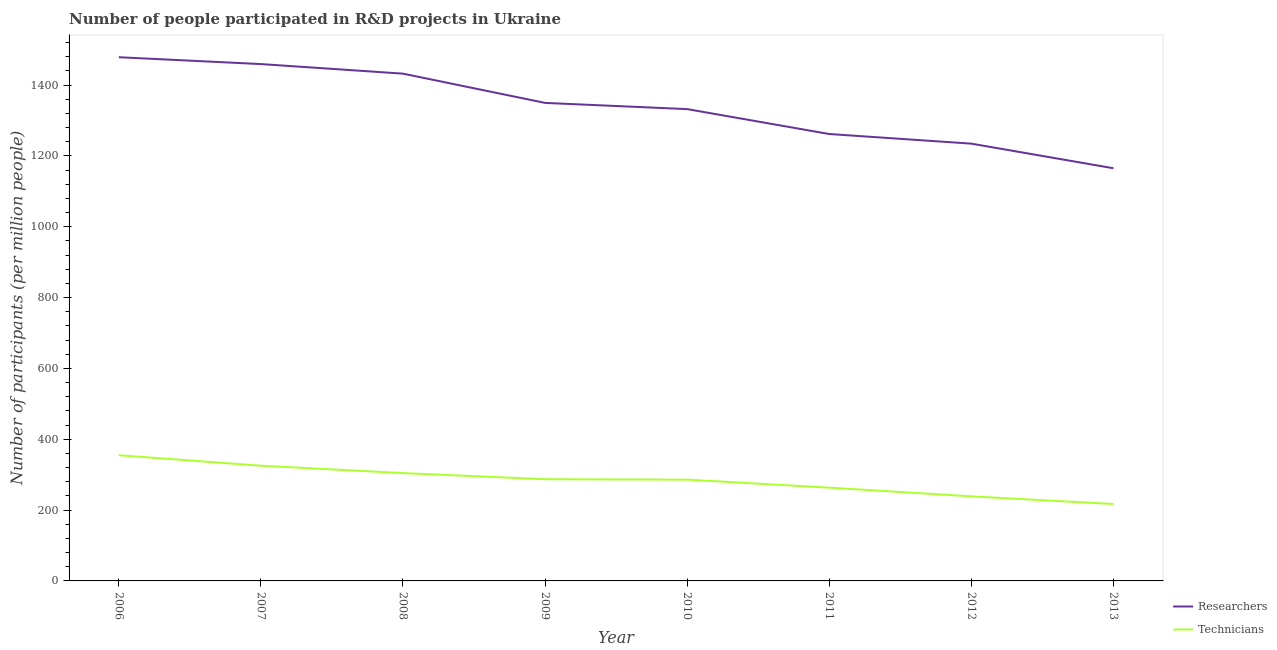How many different coloured lines are there?
Keep it short and to the point. 2. What is the number of researchers in 2011?
Make the answer very short. 1261.86. Across all years, what is the maximum number of technicians?
Make the answer very short. 354.95. Across all years, what is the minimum number of technicians?
Make the answer very short. 217.23. In which year was the number of technicians minimum?
Your answer should be very brief. 2013. What is the total number of technicians in the graph?
Your response must be concise. 2277.25. What is the difference between the number of researchers in 2010 and that in 2012?
Keep it short and to the point. 97.54. What is the difference between the number of researchers in 2010 and the number of technicians in 2011?
Give a very brief answer. 1068.84. What is the average number of researchers per year?
Your answer should be compact. 1339.25. In the year 2009, what is the difference between the number of technicians and number of researchers?
Keep it short and to the point. -1062.52. In how many years, is the number of technicians greater than 40?
Offer a very short reply. 8. What is the ratio of the number of technicians in 2009 to that in 2012?
Offer a terse response. 1.2. Is the number of technicians in 2009 less than that in 2012?
Ensure brevity in your answer.  No. What is the difference between the highest and the second highest number of researchers?
Ensure brevity in your answer.  19.39. What is the difference between the highest and the lowest number of researchers?
Your response must be concise. 313.53. Is the sum of the number of technicians in 2009 and 2012 greater than the maximum number of researchers across all years?
Provide a short and direct response. No. Does the number of researchers monotonically increase over the years?
Offer a very short reply. No. Is the number of researchers strictly greater than the number of technicians over the years?
Your answer should be very brief. Yes. How many lines are there?
Your answer should be very brief. 2. How many legend labels are there?
Your response must be concise. 2. What is the title of the graph?
Keep it short and to the point. Number of people participated in R&D projects in Ukraine. What is the label or title of the Y-axis?
Keep it short and to the point. Number of participants (per million people). What is the Number of participants (per million people) of Researchers in 2006?
Offer a terse response. 1478.72. What is the Number of participants (per million people) in Technicians in 2006?
Your answer should be very brief. 354.95. What is the Number of participants (per million people) in Researchers in 2007?
Keep it short and to the point. 1459.32. What is the Number of participants (per million people) in Technicians in 2007?
Offer a very short reply. 325.3. What is the Number of participants (per million people) in Researchers in 2008?
Provide a succinct answer. 1432.33. What is the Number of participants (per million people) of Technicians in 2008?
Give a very brief answer. 304.47. What is the Number of participants (per million people) in Researchers in 2009?
Your response must be concise. 1349.71. What is the Number of participants (per million people) of Technicians in 2009?
Your response must be concise. 287.19. What is the Number of participants (per million people) of Researchers in 2010?
Your answer should be compact. 1332.2. What is the Number of participants (per million people) of Technicians in 2010?
Ensure brevity in your answer.  285.95. What is the Number of participants (per million people) of Researchers in 2011?
Your answer should be very brief. 1261.86. What is the Number of participants (per million people) in Technicians in 2011?
Provide a succinct answer. 263.36. What is the Number of participants (per million people) of Researchers in 2012?
Keep it short and to the point. 1234.66. What is the Number of participants (per million people) of Technicians in 2012?
Offer a very short reply. 238.79. What is the Number of participants (per million people) in Researchers in 2013?
Keep it short and to the point. 1165.18. What is the Number of participants (per million people) of Technicians in 2013?
Offer a terse response. 217.23. Across all years, what is the maximum Number of participants (per million people) in Researchers?
Your response must be concise. 1478.72. Across all years, what is the maximum Number of participants (per million people) in Technicians?
Your answer should be compact. 354.95. Across all years, what is the minimum Number of participants (per million people) in Researchers?
Provide a short and direct response. 1165.18. Across all years, what is the minimum Number of participants (per million people) of Technicians?
Make the answer very short. 217.23. What is the total Number of participants (per million people) of Researchers in the graph?
Keep it short and to the point. 1.07e+04. What is the total Number of participants (per million people) of Technicians in the graph?
Provide a short and direct response. 2277.25. What is the difference between the Number of participants (per million people) in Researchers in 2006 and that in 2007?
Offer a terse response. 19.39. What is the difference between the Number of participants (per million people) in Technicians in 2006 and that in 2007?
Keep it short and to the point. 29.65. What is the difference between the Number of participants (per million people) of Researchers in 2006 and that in 2008?
Provide a short and direct response. 46.39. What is the difference between the Number of participants (per million people) of Technicians in 2006 and that in 2008?
Give a very brief answer. 50.49. What is the difference between the Number of participants (per million people) of Researchers in 2006 and that in 2009?
Your answer should be compact. 129. What is the difference between the Number of participants (per million people) of Technicians in 2006 and that in 2009?
Your answer should be compact. 67.76. What is the difference between the Number of participants (per million people) in Researchers in 2006 and that in 2010?
Ensure brevity in your answer.  146.52. What is the difference between the Number of participants (per million people) in Technicians in 2006 and that in 2010?
Provide a succinct answer. 69.01. What is the difference between the Number of participants (per million people) of Researchers in 2006 and that in 2011?
Offer a very short reply. 216.86. What is the difference between the Number of participants (per million people) in Technicians in 2006 and that in 2011?
Offer a very short reply. 91.59. What is the difference between the Number of participants (per million people) in Researchers in 2006 and that in 2012?
Your answer should be very brief. 244.05. What is the difference between the Number of participants (per million people) in Technicians in 2006 and that in 2012?
Keep it short and to the point. 116.16. What is the difference between the Number of participants (per million people) in Researchers in 2006 and that in 2013?
Your answer should be compact. 313.53. What is the difference between the Number of participants (per million people) of Technicians in 2006 and that in 2013?
Offer a terse response. 137.72. What is the difference between the Number of participants (per million people) of Researchers in 2007 and that in 2008?
Offer a very short reply. 26.99. What is the difference between the Number of participants (per million people) of Technicians in 2007 and that in 2008?
Offer a terse response. 20.83. What is the difference between the Number of participants (per million people) in Researchers in 2007 and that in 2009?
Your answer should be compact. 109.61. What is the difference between the Number of participants (per million people) in Technicians in 2007 and that in 2009?
Provide a succinct answer. 38.11. What is the difference between the Number of participants (per million people) in Researchers in 2007 and that in 2010?
Your answer should be compact. 127.12. What is the difference between the Number of participants (per million people) in Technicians in 2007 and that in 2010?
Your answer should be compact. 39.36. What is the difference between the Number of participants (per million people) of Researchers in 2007 and that in 2011?
Your answer should be very brief. 197.46. What is the difference between the Number of participants (per million people) in Technicians in 2007 and that in 2011?
Your answer should be very brief. 61.94. What is the difference between the Number of participants (per million people) in Researchers in 2007 and that in 2012?
Ensure brevity in your answer.  224.66. What is the difference between the Number of participants (per million people) in Technicians in 2007 and that in 2012?
Offer a terse response. 86.51. What is the difference between the Number of participants (per million people) in Researchers in 2007 and that in 2013?
Provide a succinct answer. 294.14. What is the difference between the Number of participants (per million people) in Technicians in 2007 and that in 2013?
Ensure brevity in your answer.  108.07. What is the difference between the Number of participants (per million people) of Researchers in 2008 and that in 2009?
Your answer should be very brief. 82.62. What is the difference between the Number of participants (per million people) of Technicians in 2008 and that in 2009?
Offer a terse response. 17.28. What is the difference between the Number of participants (per million people) of Researchers in 2008 and that in 2010?
Offer a very short reply. 100.13. What is the difference between the Number of participants (per million people) of Technicians in 2008 and that in 2010?
Your response must be concise. 18.52. What is the difference between the Number of participants (per million people) in Researchers in 2008 and that in 2011?
Offer a terse response. 170.47. What is the difference between the Number of participants (per million people) of Technicians in 2008 and that in 2011?
Give a very brief answer. 41.11. What is the difference between the Number of participants (per million people) in Researchers in 2008 and that in 2012?
Your response must be concise. 197.67. What is the difference between the Number of participants (per million people) in Technicians in 2008 and that in 2012?
Make the answer very short. 65.68. What is the difference between the Number of participants (per million people) in Researchers in 2008 and that in 2013?
Your response must be concise. 267.15. What is the difference between the Number of participants (per million people) in Technicians in 2008 and that in 2013?
Provide a short and direct response. 87.23. What is the difference between the Number of participants (per million people) of Researchers in 2009 and that in 2010?
Ensure brevity in your answer.  17.51. What is the difference between the Number of participants (per million people) in Technicians in 2009 and that in 2010?
Your answer should be very brief. 1.24. What is the difference between the Number of participants (per million people) in Researchers in 2009 and that in 2011?
Offer a very short reply. 87.85. What is the difference between the Number of participants (per million people) in Technicians in 2009 and that in 2011?
Ensure brevity in your answer.  23.83. What is the difference between the Number of participants (per million people) of Researchers in 2009 and that in 2012?
Your answer should be very brief. 115.05. What is the difference between the Number of participants (per million people) of Technicians in 2009 and that in 2012?
Your answer should be compact. 48.4. What is the difference between the Number of participants (per million people) in Researchers in 2009 and that in 2013?
Provide a short and direct response. 184.53. What is the difference between the Number of participants (per million people) of Technicians in 2009 and that in 2013?
Keep it short and to the point. 69.96. What is the difference between the Number of participants (per million people) in Researchers in 2010 and that in 2011?
Your answer should be very brief. 70.34. What is the difference between the Number of participants (per million people) in Technicians in 2010 and that in 2011?
Make the answer very short. 22.59. What is the difference between the Number of participants (per million people) in Researchers in 2010 and that in 2012?
Your answer should be very brief. 97.54. What is the difference between the Number of participants (per million people) of Technicians in 2010 and that in 2012?
Your answer should be very brief. 47.16. What is the difference between the Number of participants (per million people) in Researchers in 2010 and that in 2013?
Your answer should be compact. 167.02. What is the difference between the Number of participants (per million people) of Technicians in 2010 and that in 2013?
Offer a terse response. 68.71. What is the difference between the Number of participants (per million people) of Researchers in 2011 and that in 2012?
Your answer should be very brief. 27.2. What is the difference between the Number of participants (per million people) of Technicians in 2011 and that in 2012?
Your answer should be compact. 24.57. What is the difference between the Number of participants (per million people) in Researchers in 2011 and that in 2013?
Make the answer very short. 96.68. What is the difference between the Number of participants (per million people) in Technicians in 2011 and that in 2013?
Keep it short and to the point. 46.13. What is the difference between the Number of participants (per million people) of Researchers in 2012 and that in 2013?
Your response must be concise. 69.48. What is the difference between the Number of participants (per million people) in Technicians in 2012 and that in 2013?
Provide a short and direct response. 21.56. What is the difference between the Number of participants (per million people) of Researchers in 2006 and the Number of participants (per million people) of Technicians in 2007?
Provide a succinct answer. 1153.41. What is the difference between the Number of participants (per million people) in Researchers in 2006 and the Number of participants (per million people) in Technicians in 2008?
Provide a succinct answer. 1174.25. What is the difference between the Number of participants (per million people) of Researchers in 2006 and the Number of participants (per million people) of Technicians in 2009?
Ensure brevity in your answer.  1191.52. What is the difference between the Number of participants (per million people) of Researchers in 2006 and the Number of participants (per million people) of Technicians in 2010?
Your response must be concise. 1192.77. What is the difference between the Number of participants (per million people) in Researchers in 2006 and the Number of participants (per million people) in Technicians in 2011?
Offer a terse response. 1215.36. What is the difference between the Number of participants (per million people) in Researchers in 2006 and the Number of participants (per million people) in Technicians in 2012?
Your answer should be very brief. 1239.93. What is the difference between the Number of participants (per million people) in Researchers in 2006 and the Number of participants (per million people) in Technicians in 2013?
Offer a very short reply. 1261.48. What is the difference between the Number of participants (per million people) in Researchers in 2007 and the Number of participants (per million people) in Technicians in 2008?
Provide a succinct answer. 1154.85. What is the difference between the Number of participants (per million people) in Researchers in 2007 and the Number of participants (per million people) in Technicians in 2009?
Your response must be concise. 1172.13. What is the difference between the Number of participants (per million people) in Researchers in 2007 and the Number of participants (per million people) in Technicians in 2010?
Your answer should be very brief. 1173.37. What is the difference between the Number of participants (per million people) of Researchers in 2007 and the Number of participants (per million people) of Technicians in 2011?
Provide a short and direct response. 1195.96. What is the difference between the Number of participants (per million people) in Researchers in 2007 and the Number of participants (per million people) in Technicians in 2012?
Your response must be concise. 1220.53. What is the difference between the Number of participants (per million people) of Researchers in 2007 and the Number of participants (per million people) of Technicians in 2013?
Your response must be concise. 1242.09. What is the difference between the Number of participants (per million people) in Researchers in 2008 and the Number of participants (per million people) in Technicians in 2009?
Provide a short and direct response. 1145.14. What is the difference between the Number of participants (per million people) of Researchers in 2008 and the Number of participants (per million people) of Technicians in 2010?
Give a very brief answer. 1146.38. What is the difference between the Number of participants (per million people) in Researchers in 2008 and the Number of participants (per million people) in Technicians in 2011?
Your answer should be very brief. 1168.97. What is the difference between the Number of participants (per million people) of Researchers in 2008 and the Number of participants (per million people) of Technicians in 2012?
Make the answer very short. 1193.54. What is the difference between the Number of participants (per million people) in Researchers in 2008 and the Number of participants (per million people) in Technicians in 2013?
Make the answer very short. 1215.1. What is the difference between the Number of participants (per million people) in Researchers in 2009 and the Number of participants (per million people) in Technicians in 2010?
Give a very brief answer. 1063.76. What is the difference between the Number of participants (per million people) in Researchers in 2009 and the Number of participants (per million people) in Technicians in 2011?
Provide a succinct answer. 1086.35. What is the difference between the Number of participants (per million people) in Researchers in 2009 and the Number of participants (per million people) in Technicians in 2012?
Ensure brevity in your answer.  1110.92. What is the difference between the Number of participants (per million people) in Researchers in 2009 and the Number of participants (per million people) in Technicians in 2013?
Ensure brevity in your answer.  1132.48. What is the difference between the Number of participants (per million people) in Researchers in 2010 and the Number of participants (per million people) in Technicians in 2011?
Give a very brief answer. 1068.84. What is the difference between the Number of participants (per million people) of Researchers in 2010 and the Number of participants (per million people) of Technicians in 2012?
Offer a very short reply. 1093.41. What is the difference between the Number of participants (per million people) in Researchers in 2010 and the Number of participants (per million people) in Technicians in 2013?
Make the answer very short. 1114.96. What is the difference between the Number of participants (per million people) of Researchers in 2011 and the Number of participants (per million people) of Technicians in 2012?
Give a very brief answer. 1023.07. What is the difference between the Number of participants (per million people) in Researchers in 2011 and the Number of participants (per million people) in Technicians in 2013?
Provide a succinct answer. 1044.63. What is the difference between the Number of participants (per million people) in Researchers in 2012 and the Number of participants (per million people) in Technicians in 2013?
Provide a succinct answer. 1017.43. What is the average Number of participants (per million people) in Researchers per year?
Your response must be concise. 1339.25. What is the average Number of participants (per million people) of Technicians per year?
Give a very brief answer. 284.66. In the year 2006, what is the difference between the Number of participants (per million people) in Researchers and Number of participants (per million people) in Technicians?
Your response must be concise. 1123.76. In the year 2007, what is the difference between the Number of participants (per million people) in Researchers and Number of participants (per million people) in Technicians?
Make the answer very short. 1134.02. In the year 2008, what is the difference between the Number of participants (per million people) of Researchers and Number of participants (per million people) of Technicians?
Your answer should be compact. 1127.86. In the year 2009, what is the difference between the Number of participants (per million people) of Researchers and Number of participants (per million people) of Technicians?
Provide a short and direct response. 1062.52. In the year 2010, what is the difference between the Number of participants (per million people) of Researchers and Number of participants (per million people) of Technicians?
Your answer should be very brief. 1046.25. In the year 2011, what is the difference between the Number of participants (per million people) in Researchers and Number of participants (per million people) in Technicians?
Ensure brevity in your answer.  998.5. In the year 2012, what is the difference between the Number of participants (per million people) in Researchers and Number of participants (per million people) in Technicians?
Your response must be concise. 995.87. In the year 2013, what is the difference between the Number of participants (per million people) in Researchers and Number of participants (per million people) in Technicians?
Your answer should be compact. 947.95. What is the ratio of the Number of participants (per million people) of Researchers in 2006 to that in 2007?
Give a very brief answer. 1.01. What is the ratio of the Number of participants (per million people) in Technicians in 2006 to that in 2007?
Provide a succinct answer. 1.09. What is the ratio of the Number of participants (per million people) of Researchers in 2006 to that in 2008?
Your answer should be very brief. 1.03. What is the ratio of the Number of participants (per million people) in Technicians in 2006 to that in 2008?
Give a very brief answer. 1.17. What is the ratio of the Number of participants (per million people) in Researchers in 2006 to that in 2009?
Your response must be concise. 1.1. What is the ratio of the Number of participants (per million people) in Technicians in 2006 to that in 2009?
Your answer should be compact. 1.24. What is the ratio of the Number of participants (per million people) of Researchers in 2006 to that in 2010?
Keep it short and to the point. 1.11. What is the ratio of the Number of participants (per million people) of Technicians in 2006 to that in 2010?
Provide a succinct answer. 1.24. What is the ratio of the Number of participants (per million people) in Researchers in 2006 to that in 2011?
Give a very brief answer. 1.17. What is the ratio of the Number of participants (per million people) in Technicians in 2006 to that in 2011?
Your answer should be very brief. 1.35. What is the ratio of the Number of participants (per million people) in Researchers in 2006 to that in 2012?
Offer a very short reply. 1.2. What is the ratio of the Number of participants (per million people) of Technicians in 2006 to that in 2012?
Provide a succinct answer. 1.49. What is the ratio of the Number of participants (per million people) of Researchers in 2006 to that in 2013?
Provide a short and direct response. 1.27. What is the ratio of the Number of participants (per million people) of Technicians in 2006 to that in 2013?
Offer a very short reply. 1.63. What is the ratio of the Number of participants (per million people) in Researchers in 2007 to that in 2008?
Offer a terse response. 1.02. What is the ratio of the Number of participants (per million people) in Technicians in 2007 to that in 2008?
Offer a terse response. 1.07. What is the ratio of the Number of participants (per million people) in Researchers in 2007 to that in 2009?
Offer a terse response. 1.08. What is the ratio of the Number of participants (per million people) in Technicians in 2007 to that in 2009?
Give a very brief answer. 1.13. What is the ratio of the Number of participants (per million people) in Researchers in 2007 to that in 2010?
Ensure brevity in your answer.  1.1. What is the ratio of the Number of participants (per million people) of Technicians in 2007 to that in 2010?
Your answer should be very brief. 1.14. What is the ratio of the Number of participants (per million people) in Researchers in 2007 to that in 2011?
Your answer should be very brief. 1.16. What is the ratio of the Number of participants (per million people) in Technicians in 2007 to that in 2011?
Make the answer very short. 1.24. What is the ratio of the Number of participants (per million people) in Researchers in 2007 to that in 2012?
Your answer should be very brief. 1.18. What is the ratio of the Number of participants (per million people) in Technicians in 2007 to that in 2012?
Provide a succinct answer. 1.36. What is the ratio of the Number of participants (per million people) in Researchers in 2007 to that in 2013?
Give a very brief answer. 1.25. What is the ratio of the Number of participants (per million people) of Technicians in 2007 to that in 2013?
Give a very brief answer. 1.5. What is the ratio of the Number of participants (per million people) in Researchers in 2008 to that in 2009?
Make the answer very short. 1.06. What is the ratio of the Number of participants (per million people) of Technicians in 2008 to that in 2009?
Give a very brief answer. 1.06. What is the ratio of the Number of participants (per million people) of Researchers in 2008 to that in 2010?
Keep it short and to the point. 1.08. What is the ratio of the Number of participants (per million people) of Technicians in 2008 to that in 2010?
Your answer should be compact. 1.06. What is the ratio of the Number of participants (per million people) in Researchers in 2008 to that in 2011?
Your response must be concise. 1.14. What is the ratio of the Number of participants (per million people) in Technicians in 2008 to that in 2011?
Your answer should be compact. 1.16. What is the ratio of the Number of participants (per million people) of Researchers in 2008 to that in 2012?
Provide a short and direct response. 1.16. What is the ratio of the Number of participants (per million people) of Technicians in 2008 to that in 2012?
Your answer should be compact. 1.28. What is the ratio of the Number of participants (per million people) in Researchers in 2008 to that in 2013?
Ensure brevity in your answer.  1.23. What is the ratio of the Number of participants (per million people) of Technicians in 2008 to that in 2013?
Offer a terse response. 1.4. What is the ratio of the Number of participants (per million people) of Researchers in 2009 to that in 2010?
Make the answer very short. 1.01. What is the ratio of the Number of participants (per million people) in Researchers in 2009 to that in 2011?
Give a very brief answer. 1.07. What is the ratio of the Number of participants (per million people) in Technicians in 2009 to that in 2011?
Make the answer very short. 1.09. What is the ratio of the Number of participants (per million people) of Researchers in 2009 to that in 2012?
Your answer should be very brief. 1.09. What is the ratio of the Number of participants (per million people) in Technicians in 2009 to that in 2012?
Give a very brief answer. 1.2. What is the ratio of the Number of participants (per million people) of Researchers in 2009 to that in 2013?
Your response must be concise. 1.16. What is the ratio of the Number of participants (per million people) of Technicians in 2009 to that in 2013?
Your answer should be very brief. 1.32. What is the ratio of the Number of participants (per million people) of Researchers in 2010 to that in 2011?
Provide a succinct answer. 1.06. What is the ratio of the Number of participants (per million people) of Technicians in 2010 to that in 2011?
Your answer should be compact. 1.09. What is the ratio of the Number of participants (per million people) of Researchers in 2010 to that in 2012?
Keep it short and to the point. 1.08. What is the ratio of the Number of participants (per million people) in Technicians in 2010 to that in 2012?
Your answer should be compact. 1.2. What is the ratio of the Number of participants (per million people) in Researchers in 2010 to that in 2013?
Make the answer very short. 1.14. What is the ratio of the Number of participants (per million people) of Technicians in 2010 to that in 2013?
Provide a short and direct response. 1.32. What is the ratio of the Number of participants (per million people) in Researchers in 2011 to that in 2012?
Offer a terse response. 1.02. What is the ratio of the Number of participants (per million people) of Technicians in 2011 to that in 2012?
Ensure brevity in your answer.  1.1. What is the ratio of the Number of participants (per million people) in Researchers in 2011 to that in 2013?
Provide a short and direct response. 1.08. What is the ratio of the Number of participants (per million people) in Technicians in 2011 to that in 2013?
Your response must be concise. 1.21. What is the ratio of the Number of participants (per million people) of Researchers in 2012 to that in 2013?
Offer a very short reply. 1.06. What is the ratio of the Number of participants (per million people) in Technicians in 2012 to that in 2013?
Make the answer very short. 1.1. What is the difference between the highest and the second highest Number of participants (per million people) in Researchers?
Your answer should be compact. 19.39. What is the difference between the highest and the second highest Number of participants (per million people) in Technicians?
Your answer should be very brief. 29.65. What is the difference between the highest and the lowest Number of participants (per million people) in Researchers?
Give a very brief answer. 313.53. What is the difference between the highest and the lowest Number of participants (per million people) of Technicians?
Your response must be concise. 137.72. 